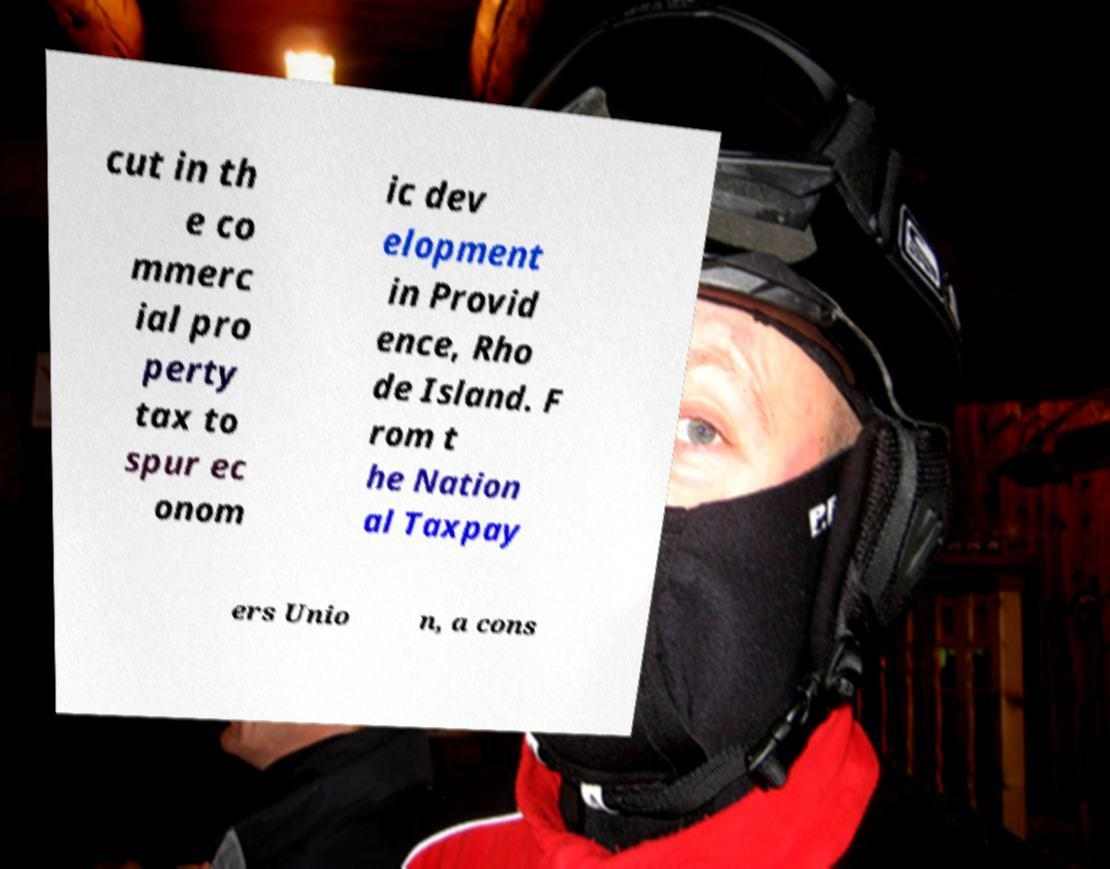What messages or text are displayed in this image? I need them in a readable, typed format. cut in th e co mmerc ial pro perty tax to spur ec onom ic dev elopment in Provid ence, Rho de Island. F rom t he Nation al Taxpay ers Unio n, a cons 